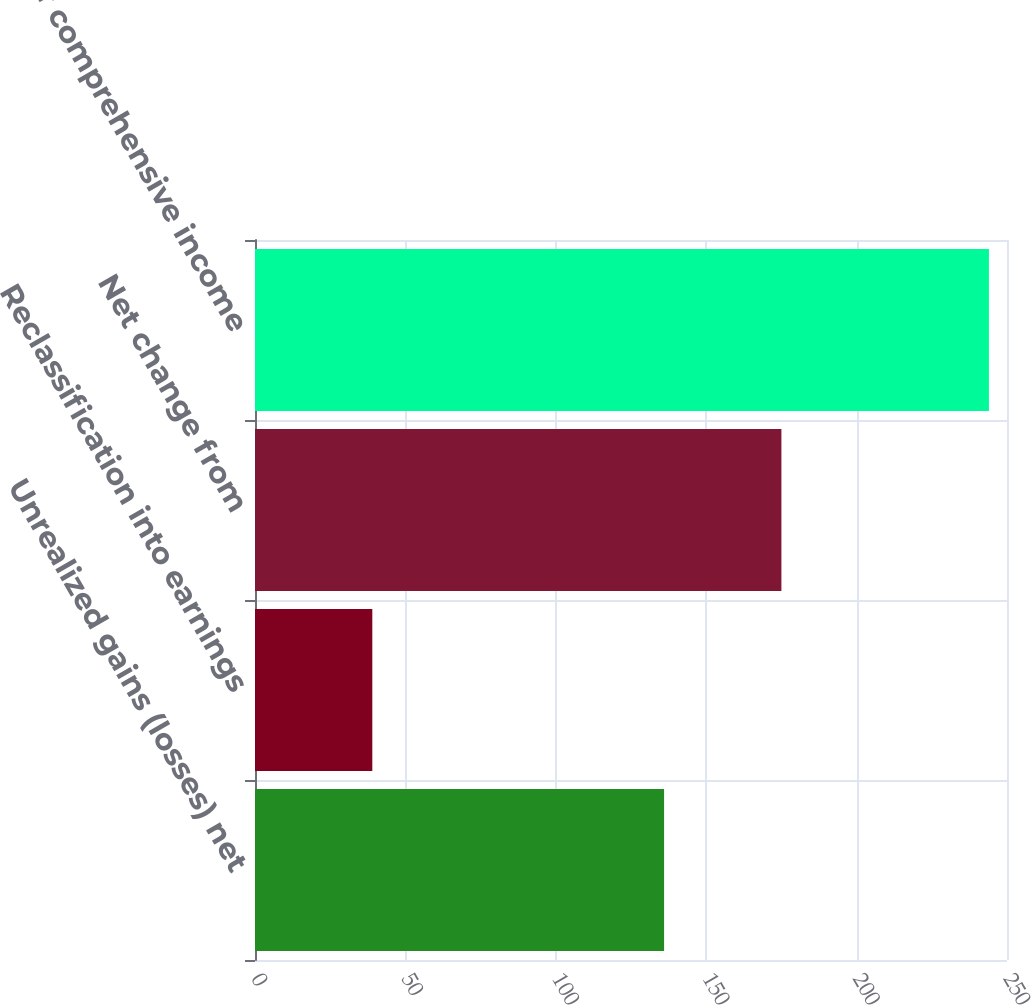<chart> <loc_0><loc_0><loc_500><loc_500><bar_chart><fcel>Unrealized gains (losses) net<fcel>Reclassification into earnings<fcel>Net change from<fcel>Other comprehensive income<nl><fcel>136<fcel>39<fcel>175<fcel>244<nl></chart> 